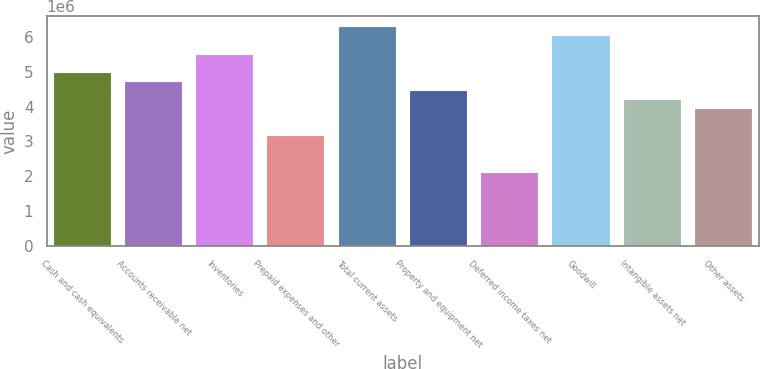Convert chart to OTSL. <chart><loc_0><loc_0><loc_500><loc_500><bar_chart><fcel>Cash and cash equivalents<fcel>Accounts receivable net<fcel>Inventories<fcel>Prepaid expenses and other<fcel>Total current assets<fcel>Property and equipment net<fcel>Deferred income taxes net<fcel>Goodwill<fcel>Intangible assets net<fcel>Other assets<nl><fcel>4.97534e+06<fcel>4.71361e+06<fcel>5.49882e+06<fcel>3.14318e+06<fcel>6.28403e+06<fcel>4.45187e+06<fcel>2.09623e+06<fcel>6.02229e+06<fcel>4.19013e+06<fcel>3.92839e+06<nl></chart> 